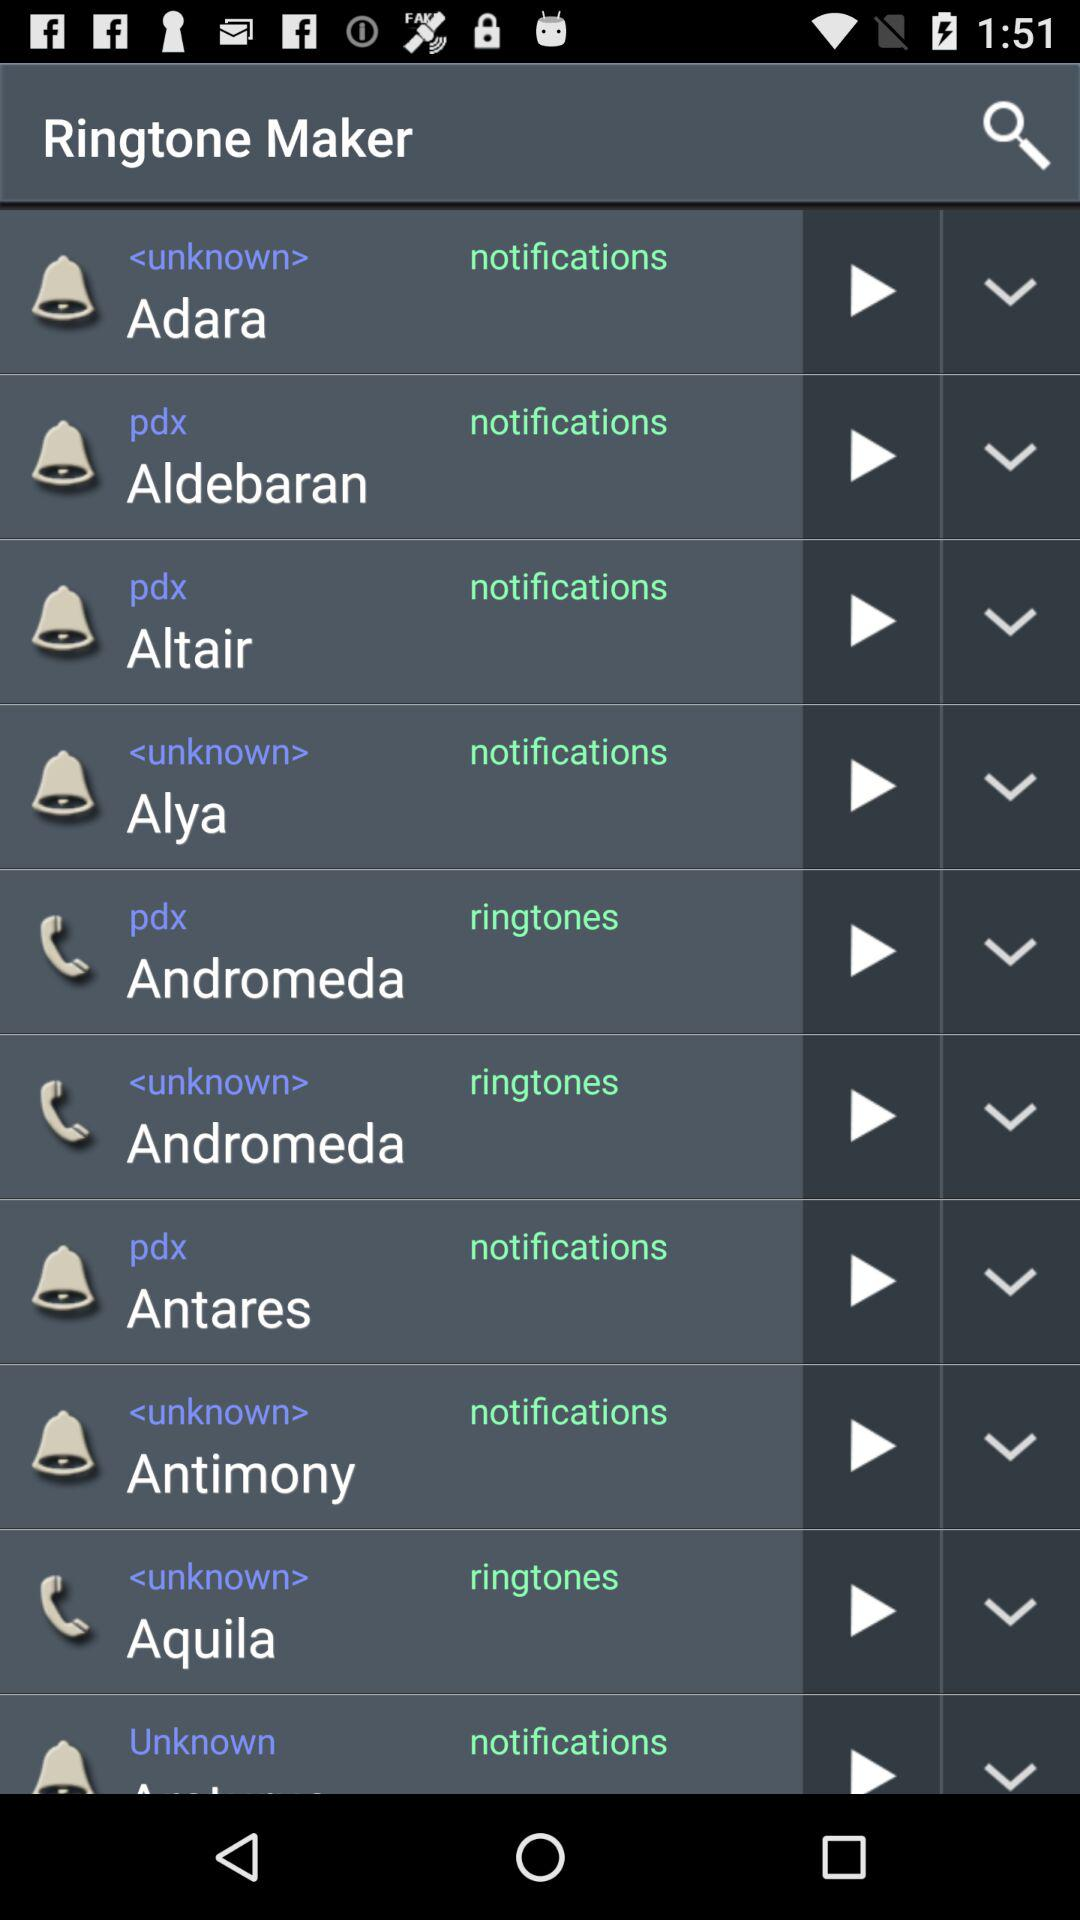What is the application name? The application name is "Ringtone Maker". 